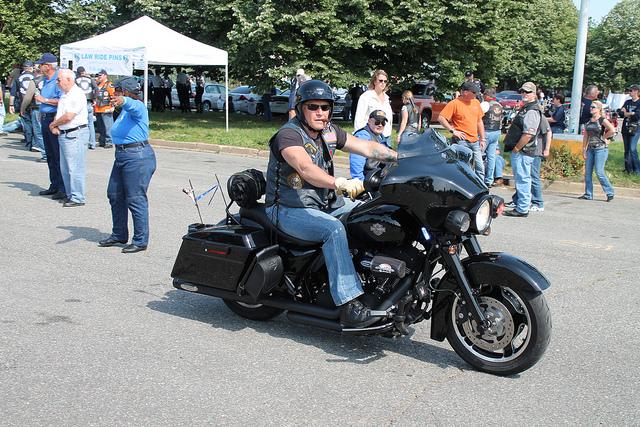Is the bike moving?
Be succinct. No. What is the rider wearing on his head?
Answer briefly. Helmet. How many policeman are pictured?
Be succinct. 0. Why is the man wearing a bright orange top?
Short answer required. He likes it. Is the guy riding a motorcycle?
Answer briefly. Yes. What kind of motorcycle is this?
Give a very brief answer. Harley. How many riders are on the black motorcycle?
Answer briefly. 1. 